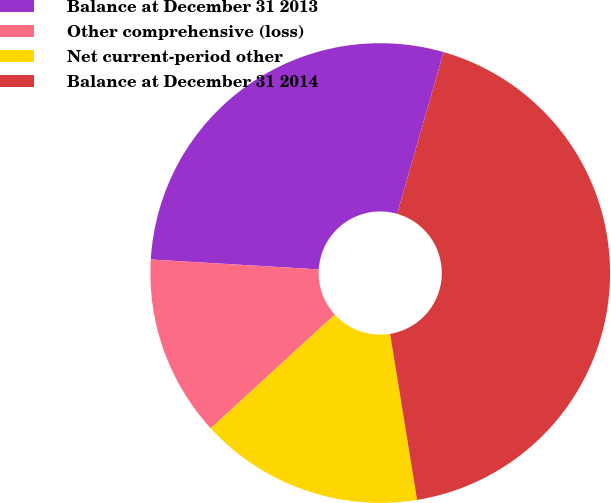Convert chart. <chart><loc_0><loc_0><loc_500><loc_500><pie_chart><fcel>Balance at December 31 2013<fcel>Other comprehensive (loss)<fcel>Net current-period other<fcel>Balance at December 31 2014<nl><fcel>28.51%<fcel>12.74%<fcel>15.76%<fcel>42.99%<nl></chart> 